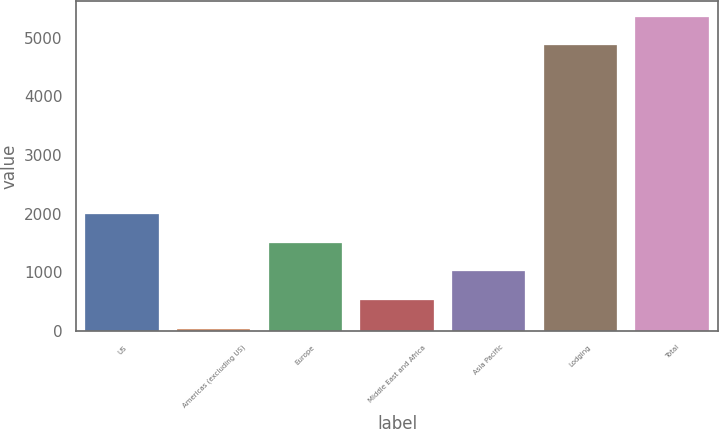<chart> <loc_0><loc_0><loc_500><loc_500><bar_chart><fcel>US<fcel>Americas (excluding US)<fcel>Europe<fcel>Middle East and Africa<fcel>Asia Pacific<fcel>Lodging<fcel>Total<nl><fcel>1994.6<fcel>43<fcel>1506.7<fcel>530.9<fcel>1018.8<fcel>4875<fcel>5362.9<nl></chart> 